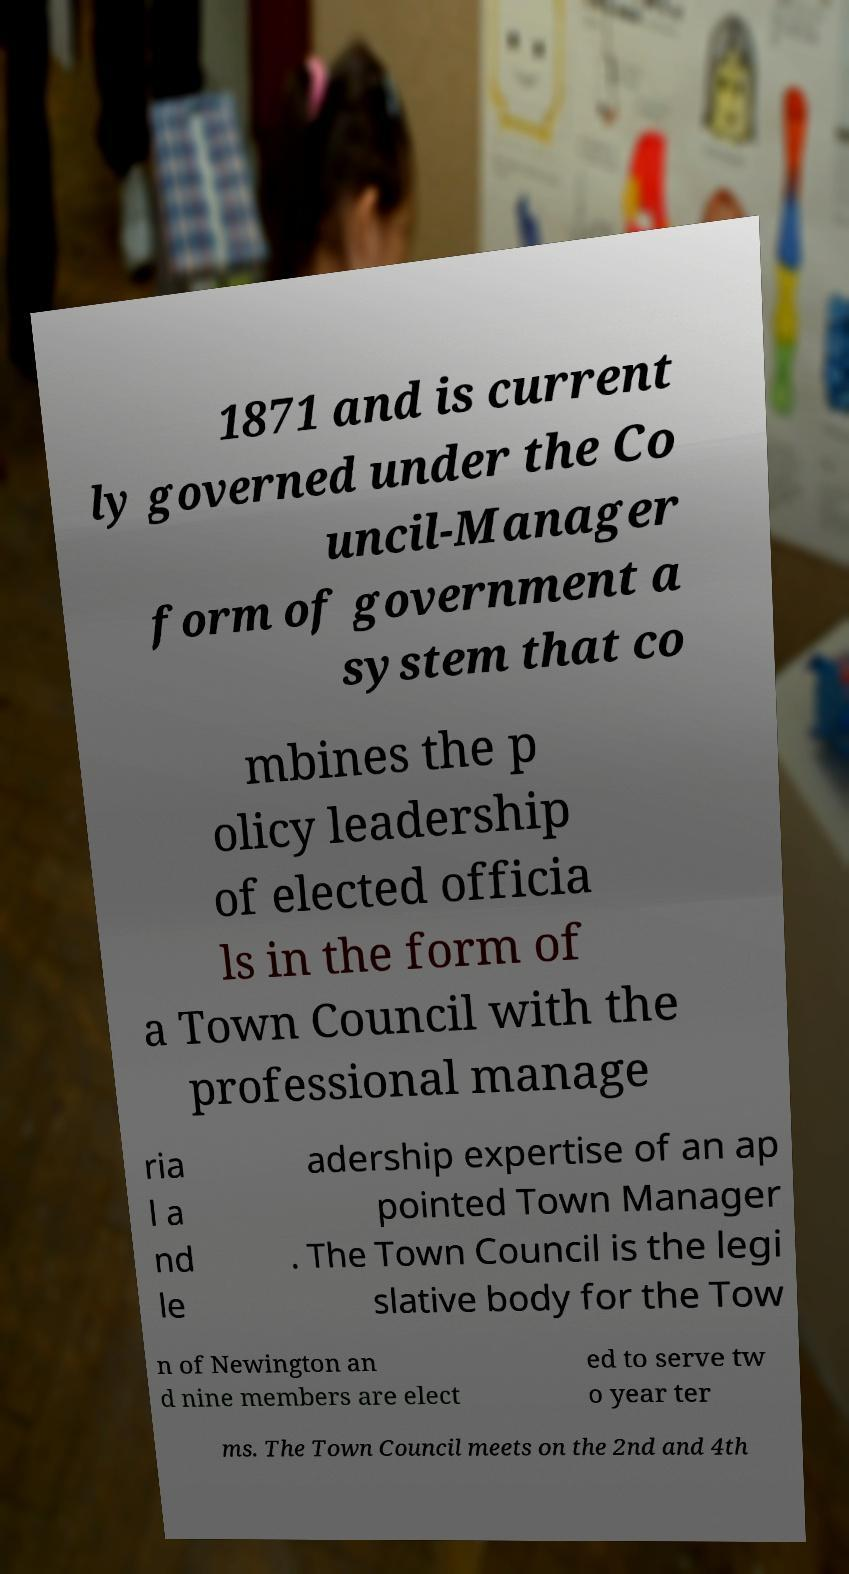Can you accurately transcribe the text from the provided image for me? 1871 and is current ly governed under the Co uncil-Manager form of government a system that co mbines the p olicy leadership of elected officia ls in the form of a Town Council with the professional manage ria l a nd le adership expertise of an ap pointed Town Manager . The Town Council is the legi slative body for the Tow n of Newington an d nine members are elect ed to serve tw o year ter ms. The Town Council meets on the 2nd and 4th 